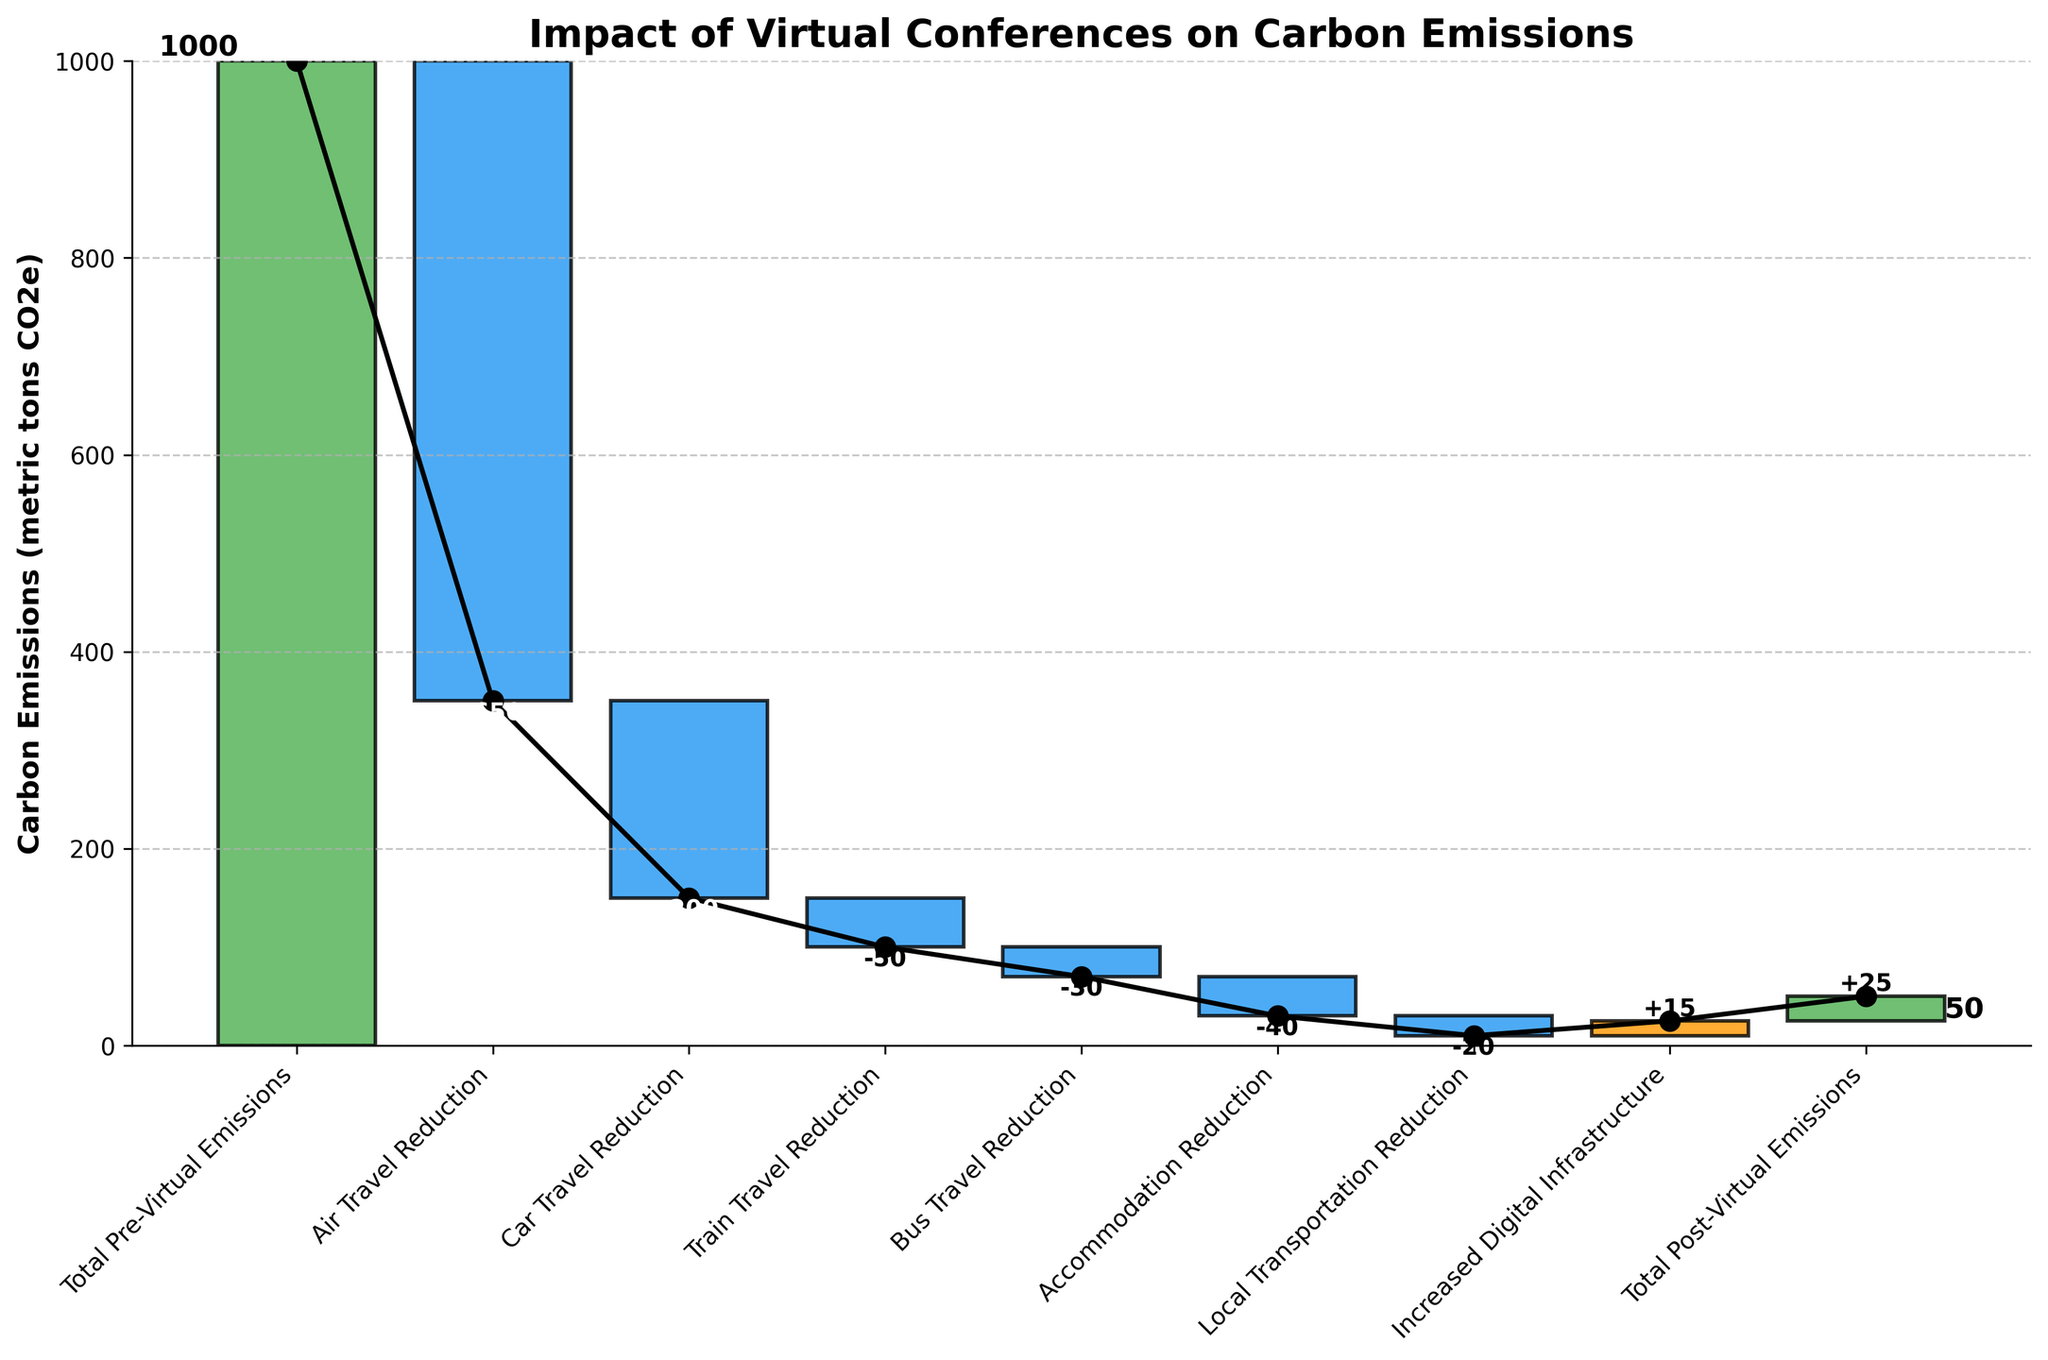What's the title of the chart? The title is written at the top of the chart. In this case, the title is "Impact of Virtual Conferences on Carbon Emissions".
Answer: Impact of Virtual Conferences on Carbon Emissions What is the value of 'Total Pre-Virtual Emissions'? The value is the starting point of the first bar on the left of the chart. It's labeled as 'Total Pre-Virtual Emissions' with a positive value.
Answer: 1000 Which category shows the largest reduction in carbon emissions? The category with the largest reduction will have the longest bar going downward. 'Air Travel Reduction' has the longest downward bar.
Answer: Air Travel Reduction What is the cumulative value of emissions reduction from 'Air Travel', 'Car Travel', and 'Train Travel'? Add the absolute values of the reductions from these categories: 650 (Air Travel) + 200 (Car Travel) + 50 (Train Travel) = 900
Answer: 900 How much have the emissions increased due to 'Increased Digital Infrastructure'? The emissions increase is represented by a small upward bar labeled 'Increased Digital Infrastructure'.
Answer: 15 What is the final value of 'Total Post-Virtual Emissions'? The final value is at the end of the last cumulative bar on the right, labeled 'Total Post-Virtual Emissions'.
Answer: 25 How does the reduction from 'Accommodation' compare to 'Local Transportation'? Compare the values of reductions for both categories. 'Accommodation Reduction' is -40, and 'Local Transportation Reduction' is -20. 'Accommodation Reduction' is double that of 'Local Transportation Reduction'.
Answer: Accommodation Reduction is double Local Transportation Reduction Summarize the total reduction in carbon emissions due to all types of travel combined ('Air', 'Car', 'Train', 'Bus'). Sum up the reductions from 'Air Travel', 'Car Travel', 'Train Travel', and 'Bus Travel': -650 + (-200) + (-50) + (-30) = -930
Answer: -930 What is the combined reduction value of 'Local Transportation' and 'Accommodation'? Add the absolute reduction values from both categories: 20 (Local Transportation) + 40 (Accommodation) = 60
Answer: 60 